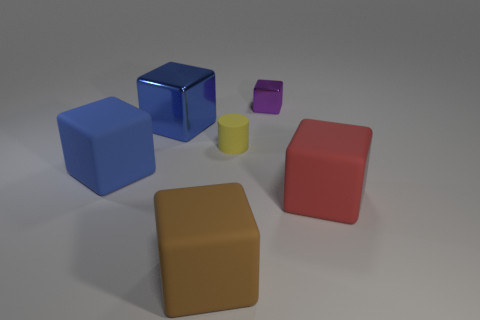Are there more metallic things behind the tiny yellow object than small yellow matte objects?
Offer a terse response. Yes. There is a big brown thing; does it have the same shape as the big rubber object that is on the right side of the purple block?
Make the answer very short. Yes. What number of big objects are cyan things or metallic cubes?
Offer a terse response. 1. There is a matte block that is the same color as the large shiny thing; what is its size?
Keep it short and to the point. Large. What color is the big object that is to the right of the tiny object that is in front of the tiny purple block?
Your response must be concise. Red. Does the large brown cube have the same material as the large blue thing in front of the small matte cylinder?
Your answer should be very brief. Yes. What material is the blue object behind the large blue matte thing?
Your answer should be compact. Metal. Are there an equal number of tiny purple cubes to the left of the purple shiny object and tiny cyan matte cylinders?
Make the answer very short. Yes. The small thing behind the blue block that is to the right of the big blue rubber block is made of what material?
Your answer should be compact. Metal. What shape is the rubber thing that is left of the big red rubber object and right of the brown thing?
Offer a terse response. Cylinder. 